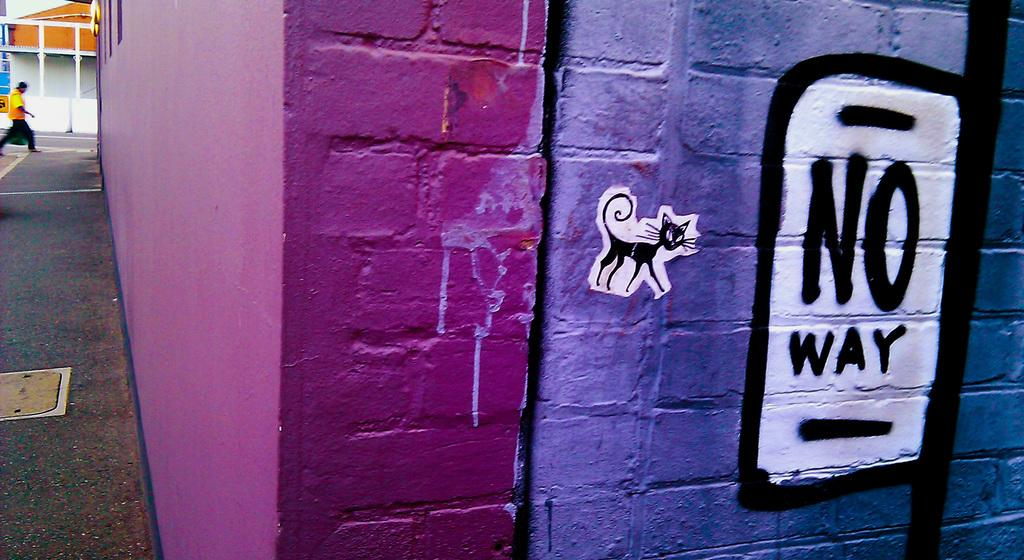What type of structure can be seen in the image? There is a wall in the image. What else is visible in the image besides the wall? There are houses in the image. Can you describe the activity of the person in the image? There is a person walking in the image. How many loaves of bread can be seen on the wall in the image? There is no bread visible on the wall in the image. 